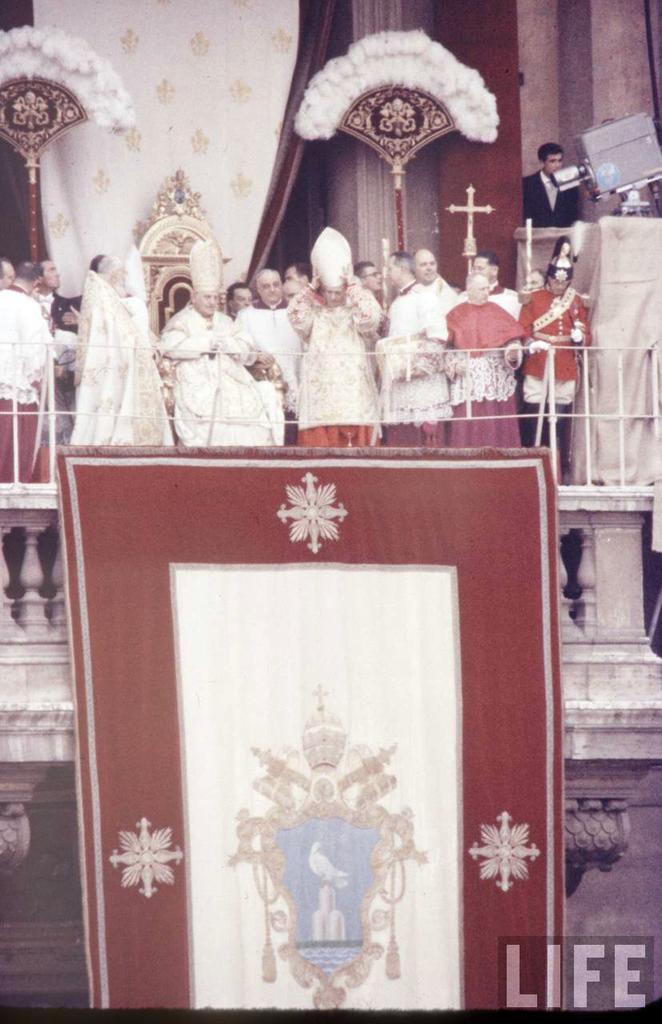Can you describe this image briefly? In this image in the center there are a group of people some of them are standing, and one person is sitting. And at the bottom there is one carpet, and in the background there are some clothes, wall, cross and some objects and in the center there is a railing. 